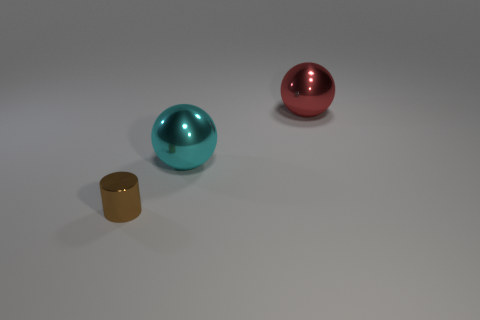Add 1 red metallic objects. How many objects exist? 4 Subtract all spheres. How many objects are left? 1 Subtract all red things. Subtract all tiny brown shiny objects. How many objects are left? 1 Add 1 big things. How many big things are left? 3 Add 3 balls. How many balls exist? 5 Subtract 0 yellow cylinders. How many objects are left? 3 